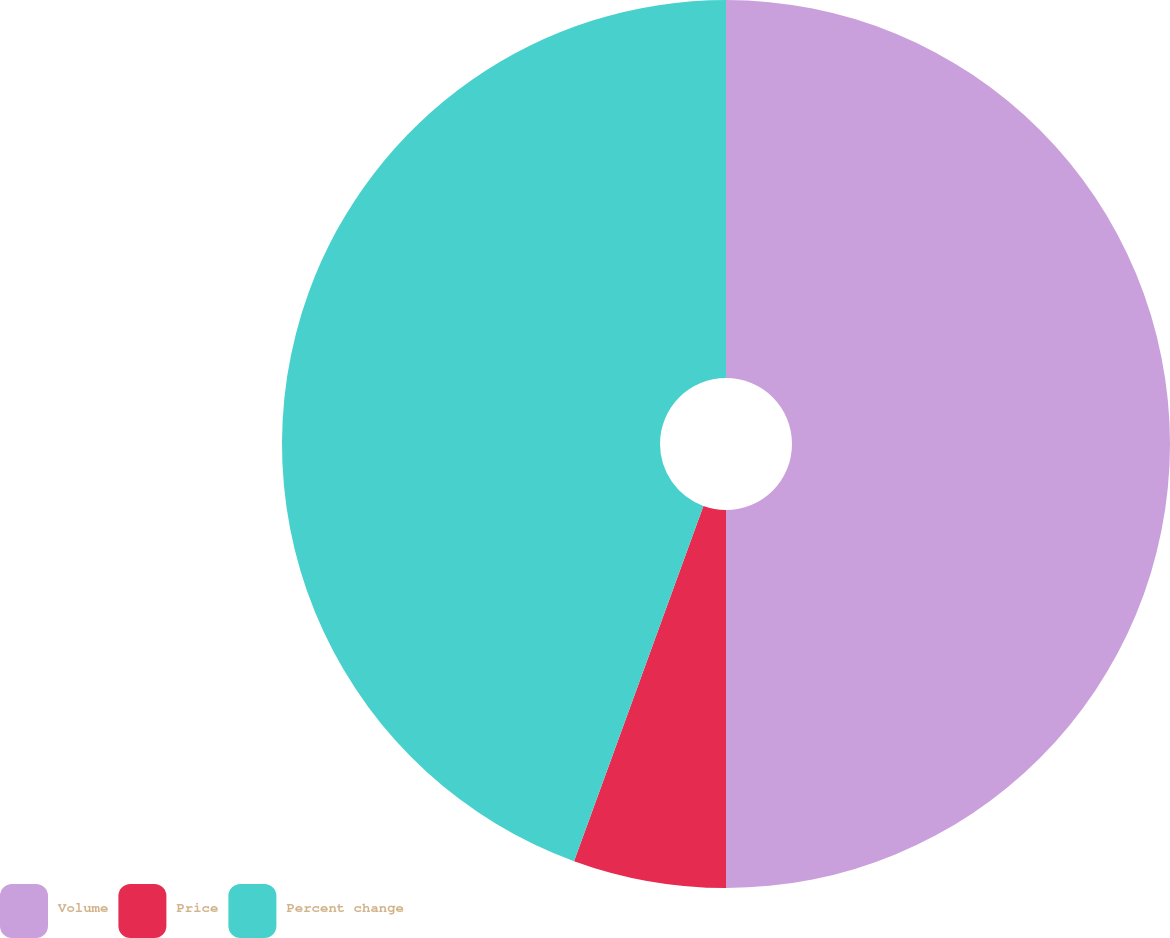Convert chart. <chart><loc_0><loc_0><loc_500><loc_500><pie_chart><fcel>Volume<fcel>Price<fcel>Percent change<nl><fcel>50.0%<fcel>5.56%<fcel>44.44%<nl></chart> 